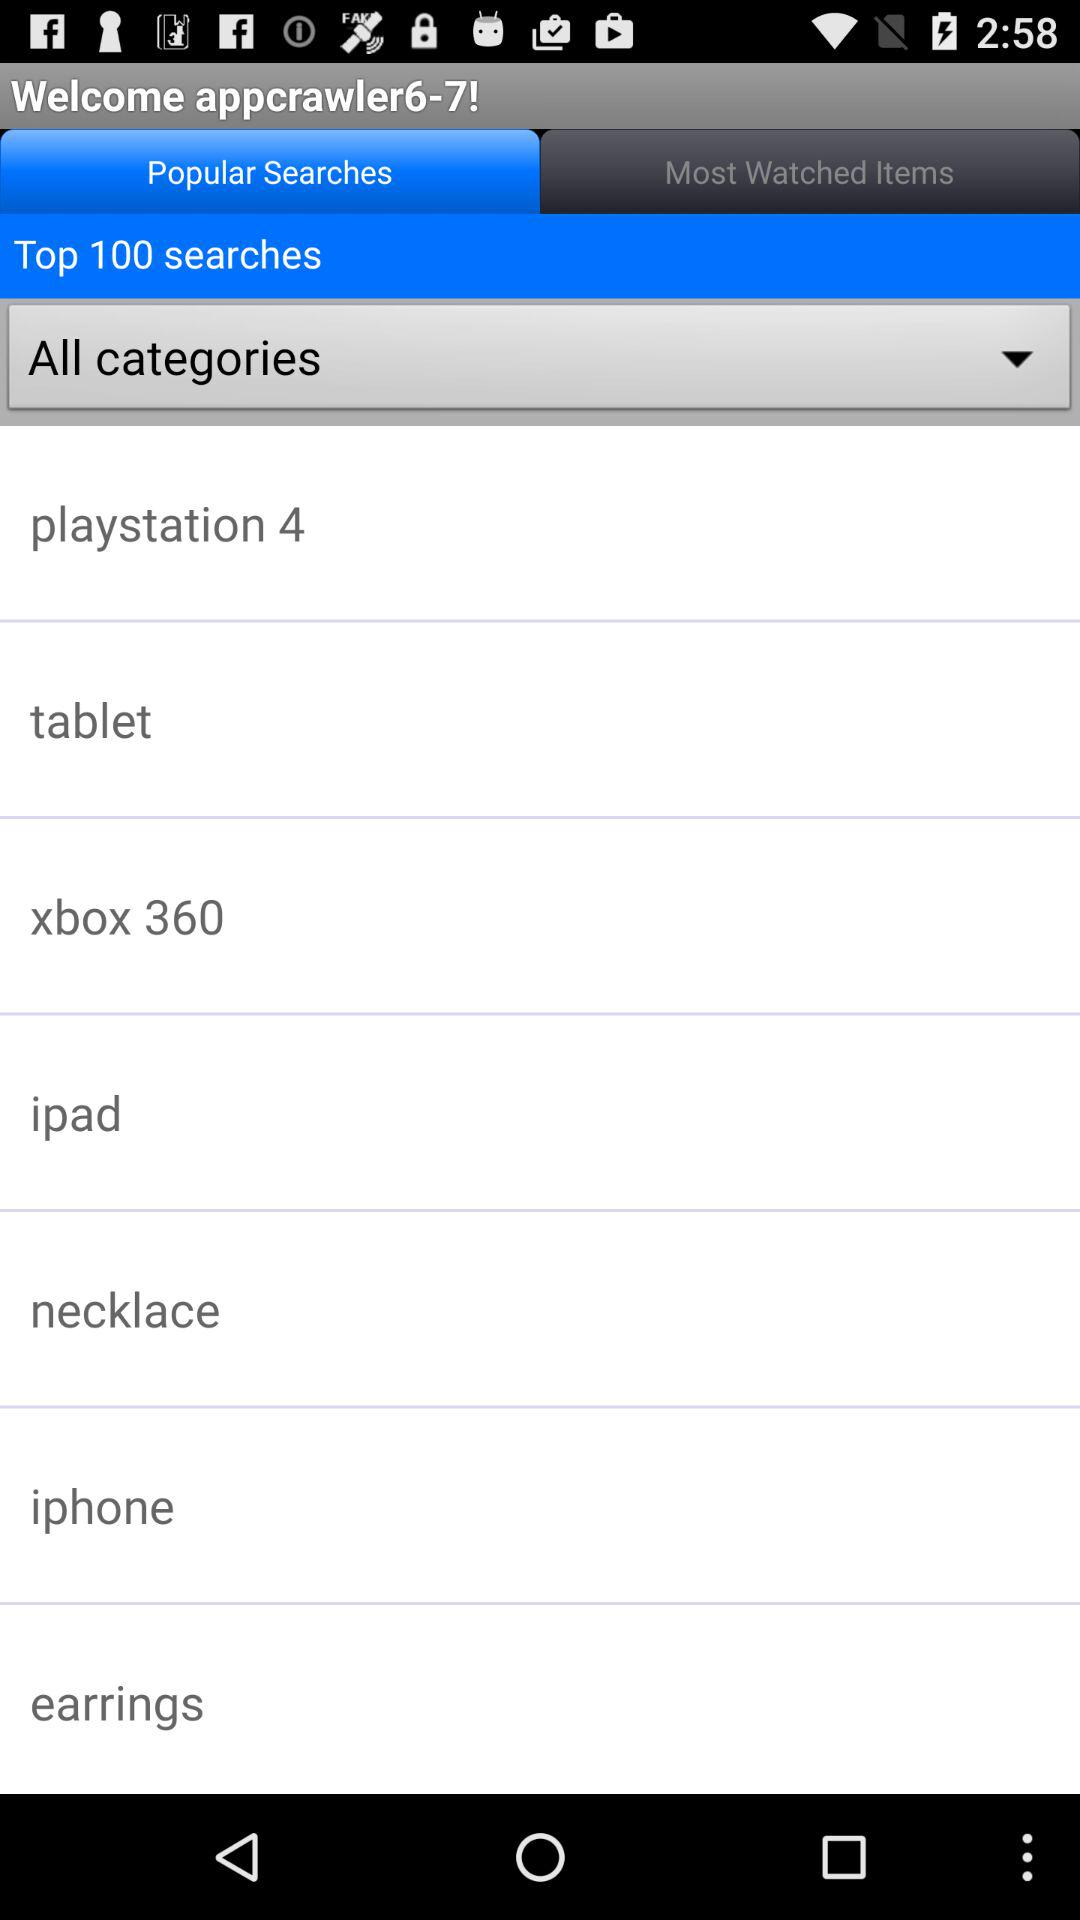Which items are the most watched?
When the provided information is insufficient, respond with <no answer>. <no answer> 